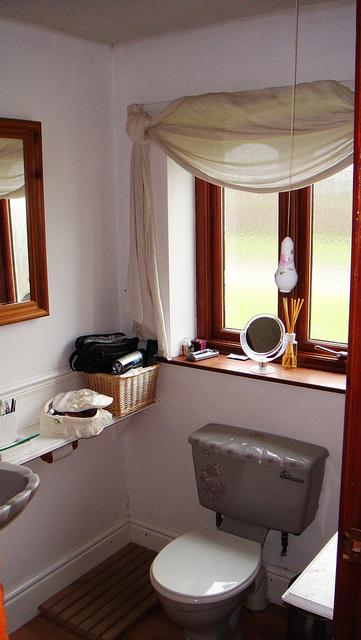Is there a mirror?
Keep it brief. Yes. What kind of items are in the basket?
Concise answer only. Toiletries. What is in the center of the picture?
Concise answer only. Toilet. 